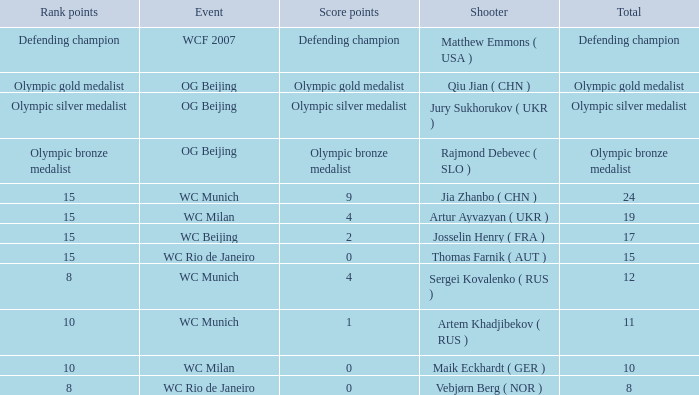I'm looking to parse the entire table for insights. Could you assist me with that? {'header': ['Rank points', 'Event', 'Score points', 'Shooter', 'Total'], 'rows': [['Defending champion', 'WCF 2007', 'Defending champion', 'Matthew Emmons ( USA )', 'Defending champion'], ['Olympic gold medalist', 'OG Beijing', 'Olympic gold medalist', 'Qiu Jian ( CHN )', 'Olympic gold medalist'], ['Olympic silver medalist', 'OG Beijing', 'Olympic silver medalist', 'Jury Sukhorukov ( UKR )', 'Olympic silver medalist'], ['Olympic bronze medalist', 'OG Beijing', 'Olympic bronze medalist', 'Rajmond Debevec ( SLO )', 'Olympic bronze medalist'], ['15', 'WC Munich', '9', 'Jia Zhanbo ( CHN )', '24'], ['15', 'WC Milan', '4', 'Artur Ayvazyan ( UKR )', '19'], ['15', 'WC Beijing', '2', 'Josselin Henry ( FRA )', '17'], ['15', 'WC Rio de Janeiro', '0', 'Thomas Farnik ( AUT )', '15'], ['8', 'WC Munich', '4', 'Sergei Kovalenko ( RUS )', '12'], ['10', 'WC Munich', '1', 'Artem Khadjibekov ( RUS )', '11'], ['10', 'WC Milan', '0', 'Maik Eckhardt ( GER )', '10'], ['8', 'WC Rio de Janeiro', '0', 'Vebjørn Berg ( NOR )', '8']]} Who was the shooter for the WC Beijing event? Josselin Henry ( FRA ). 